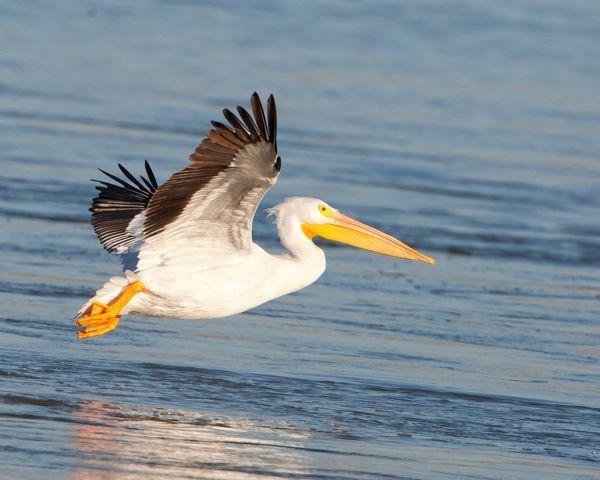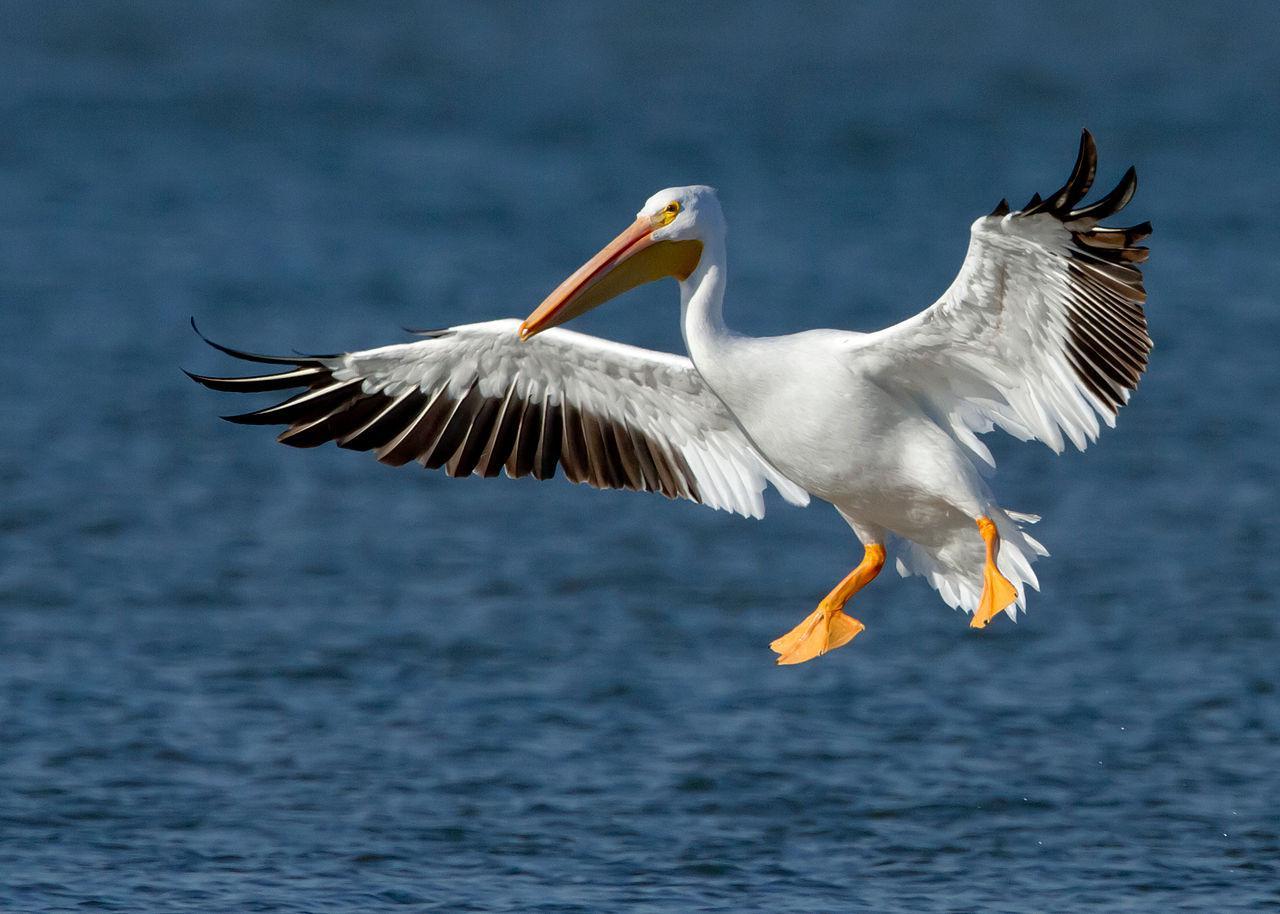The first image is the image on the left, the second image is the image on the right. Considering the images on both sides, is "Both of the birds are in the air above the water." valid? Answer yes or no. Yes. 